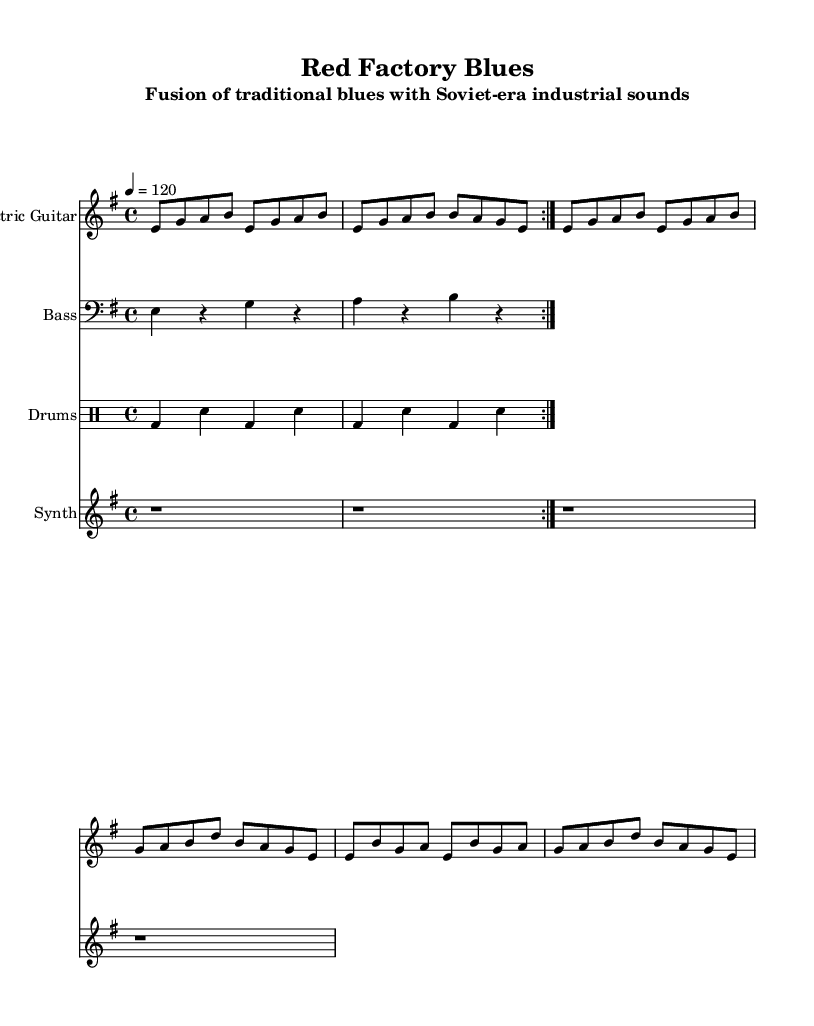What is the key signature of this music? The key signature is E minor, indicated by one sharp (F#) on the left side of the staff.
Answer: E minor What is the time signature of this music? The time signature is 4/4, shown at the beginning of the score with a '4' above and below.
Answer: 4/4 What is the tempo marking given in the score? The tempo marking is indicated by the text '4 = 120', which specifies the speed of the music.
Answer: 120 How many measures are repeated in the electric guitar part? The repeat sign indicates two measures are to be played twice. By examining the 'volta' markings, you can identify the repeated sections.
Answer: 2 What instruments are included in this composition? The score lists four instruments: Electric Guitar, Bass, Drums, and Synth. This can be determined by identifying the different staves labeled accordingly.
Answer: Electric Guitar, Bass, Drums, Synth What type of beats does the drum part predominantly use? The drum part primarily features bass drum and snare hits, as indicated by the 'bd' for bass drum and 'sn' for snare in the drum notation.
Answer: Bass and snare What genre is this composition indicative of? The title and subtitle reference the fusion of traditional blues with technical Soviet-era sounds, specifically identifying it as Electric Blues.
Answer: Electric Blues 